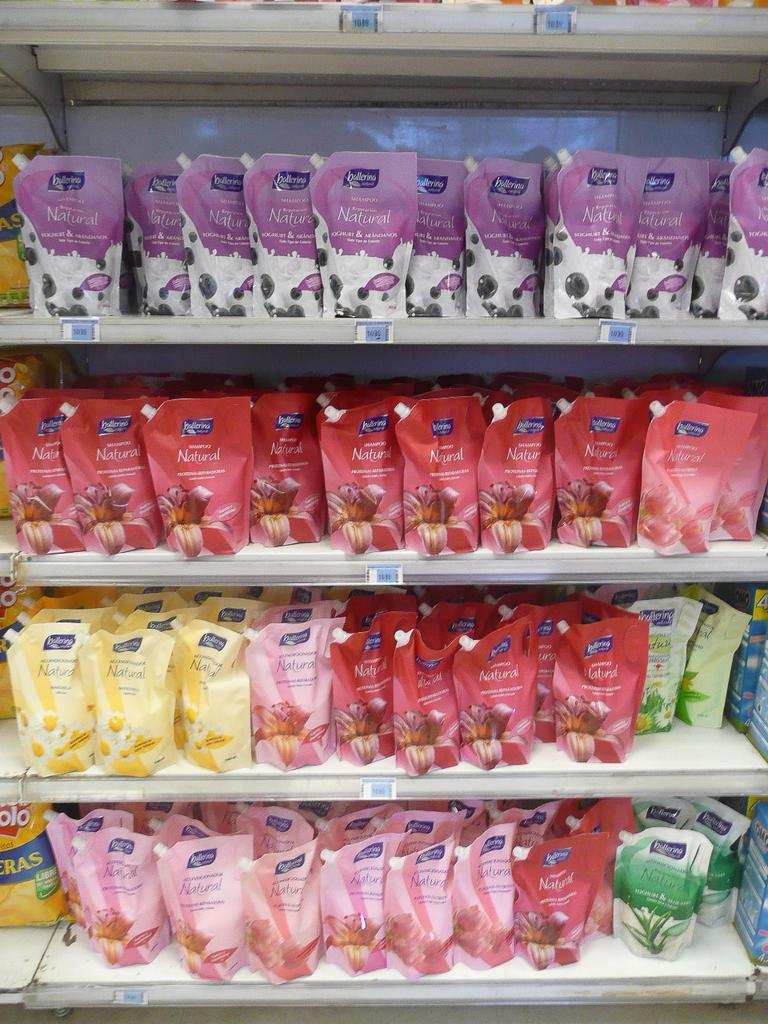<image>
Describe the image concisely. A variety of products on store shelves that are natural 